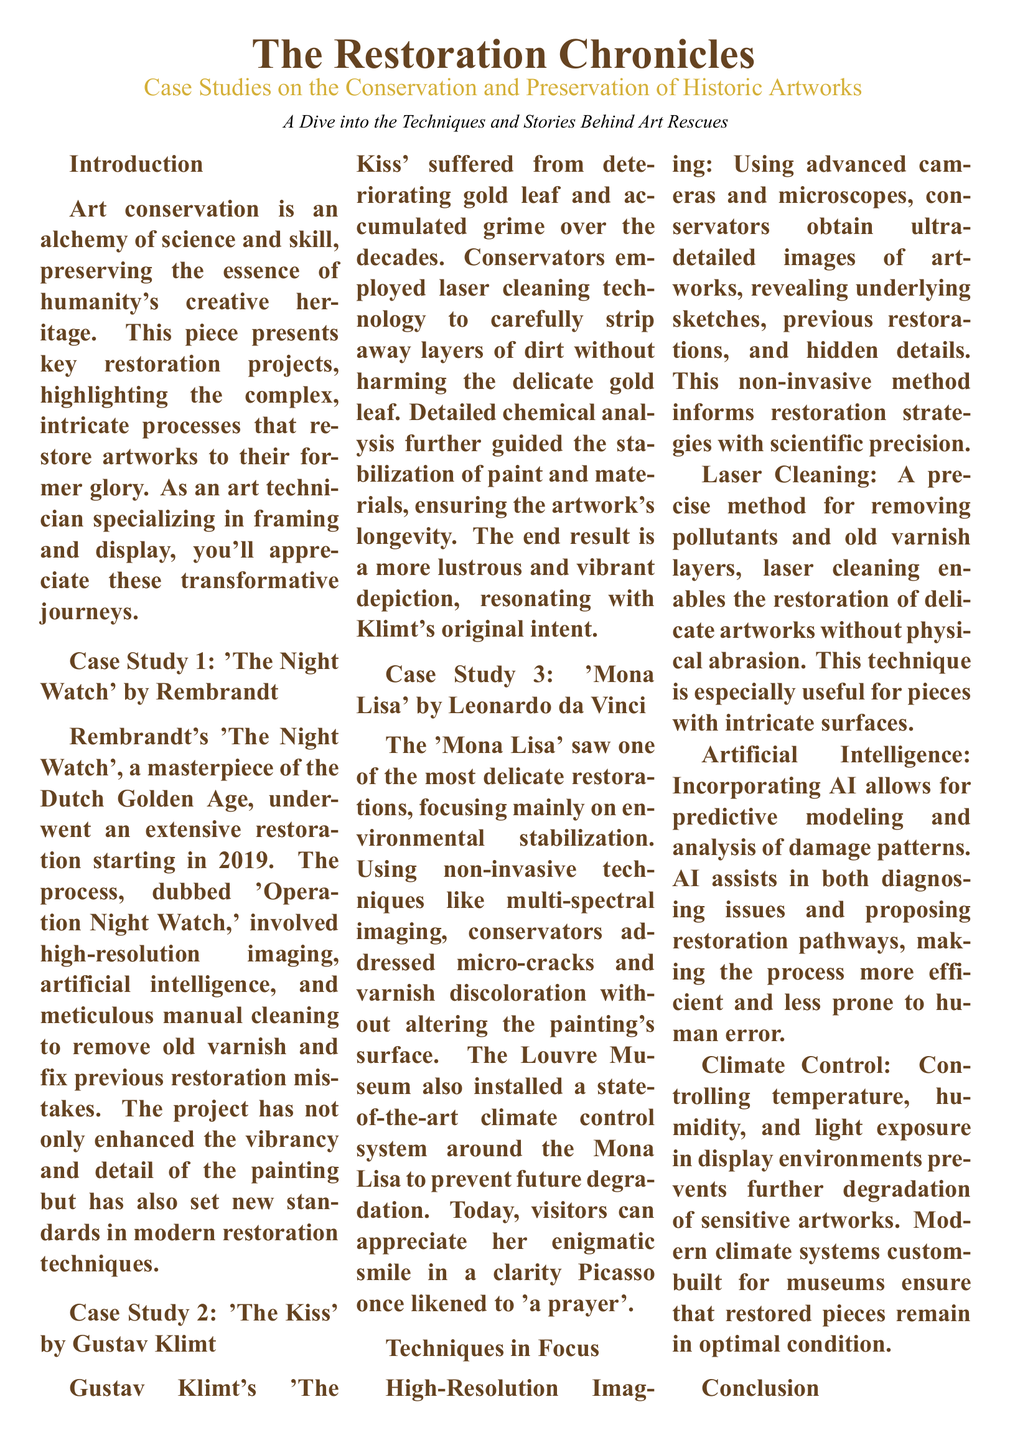What is the title of the first case study? The title of the first case study is explicitly mentioned as "Case Study 1: 'The Night Watch' by Rembrandt".
Answer: 'The Night Watch' What year did the restoration of 'The Night Watch' begin? The restoration of 'The Night Watch' began in 2019, which is provided in the case study details.
Answer: 2019 What technique was primarily used in the restoration of 'The Kiss'? The case study for 'The Kiss' illustrates that laser cleaning technology was the primary technique used for restoration.
Answer: Laser cleaning How is the 'Mona Lisa' primarily preserved? The document states that the preservation of the 'Mona Lisa' focused mainly on environmental stabilization.
Answer: Environmental stabilization Which artwork is referenced for its "enigmatic smile"? The text specifically mentions the 'Mona Lisa' in context to its "enigmatic smile".
Answer: 'Mona Lisa' What role does artificial intelligence play in art restoration according to the document? The document describes AI as playing a role in predictive modeling and analysis of damage patterns in art restoration.
Answer: Predictive modeling What is a significant result of the restoration projects mentioned? The document emphasizes that the restoration projects enhance the vibrancy and detail of the artworks, which is a significant outcome.
Answer: Enhanced vibrancy What is the color of the main title in the document? The document states that the main title is styled in the color artbrown.
Answer: artbrown 